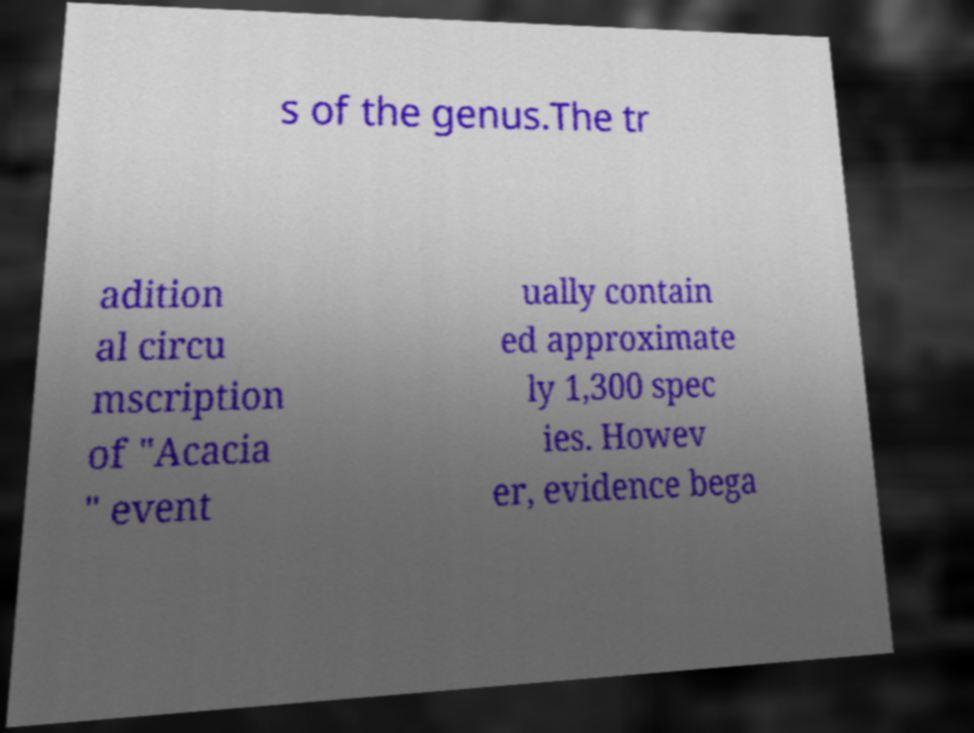Please identify and transcribe the text found in this image. s of the genus.The tr adition al circu mscription of "Acacia " event ually contain ed approximate ly 1,300 spec ies. Howev er, evidence bega 